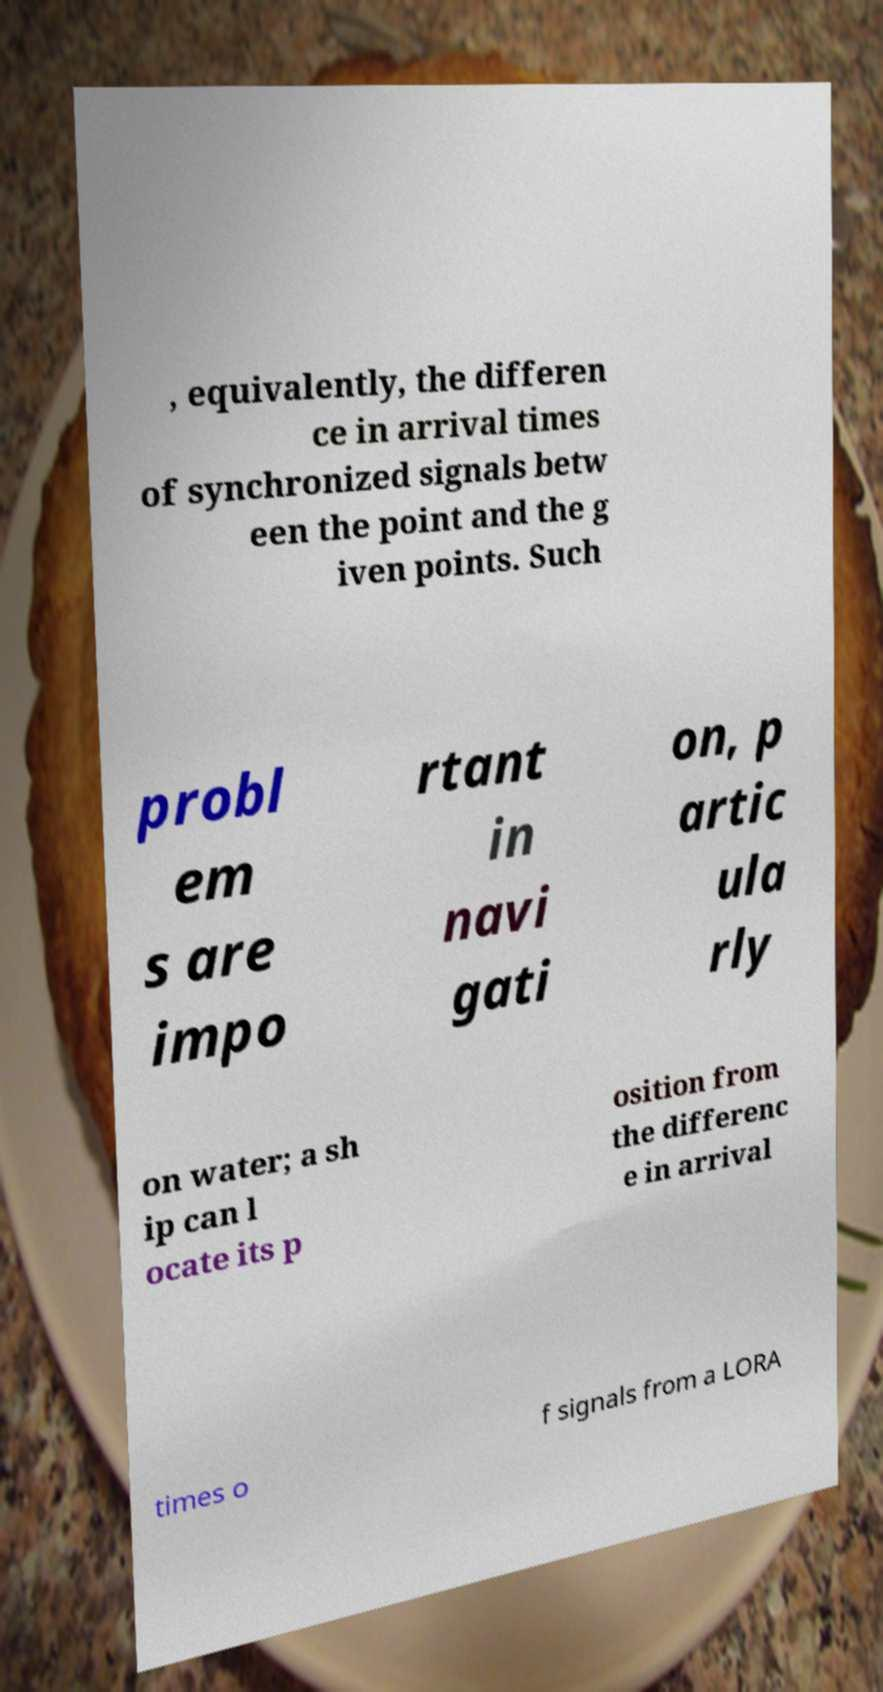For documentation purposes, I need the text within this image transcribed. Could you provide that? , equivalently, the differen ce in arrival times of synchronized signals betw een the point and the g iven points. Such probl em s are impo rtant in navi gati on, p artic ula rly on water; a sh ip can l ocate its p osition from the differenc e in arrival times o f signals from a LORA 